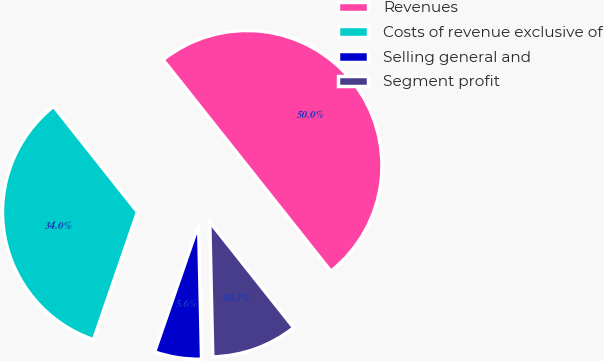Convert chart to OTSL. <chart><loc_0><loc_0><loc_500><loc_500><pie_chart><fcel>Revenues<fcel>Costs of revenue exclusive of<fcel>Selling general and<fcel>Segment profit<nl><fcel>50.0%<fcel>34.04%<fcel>5.64%<fcel>10.32%<nl></chart> 